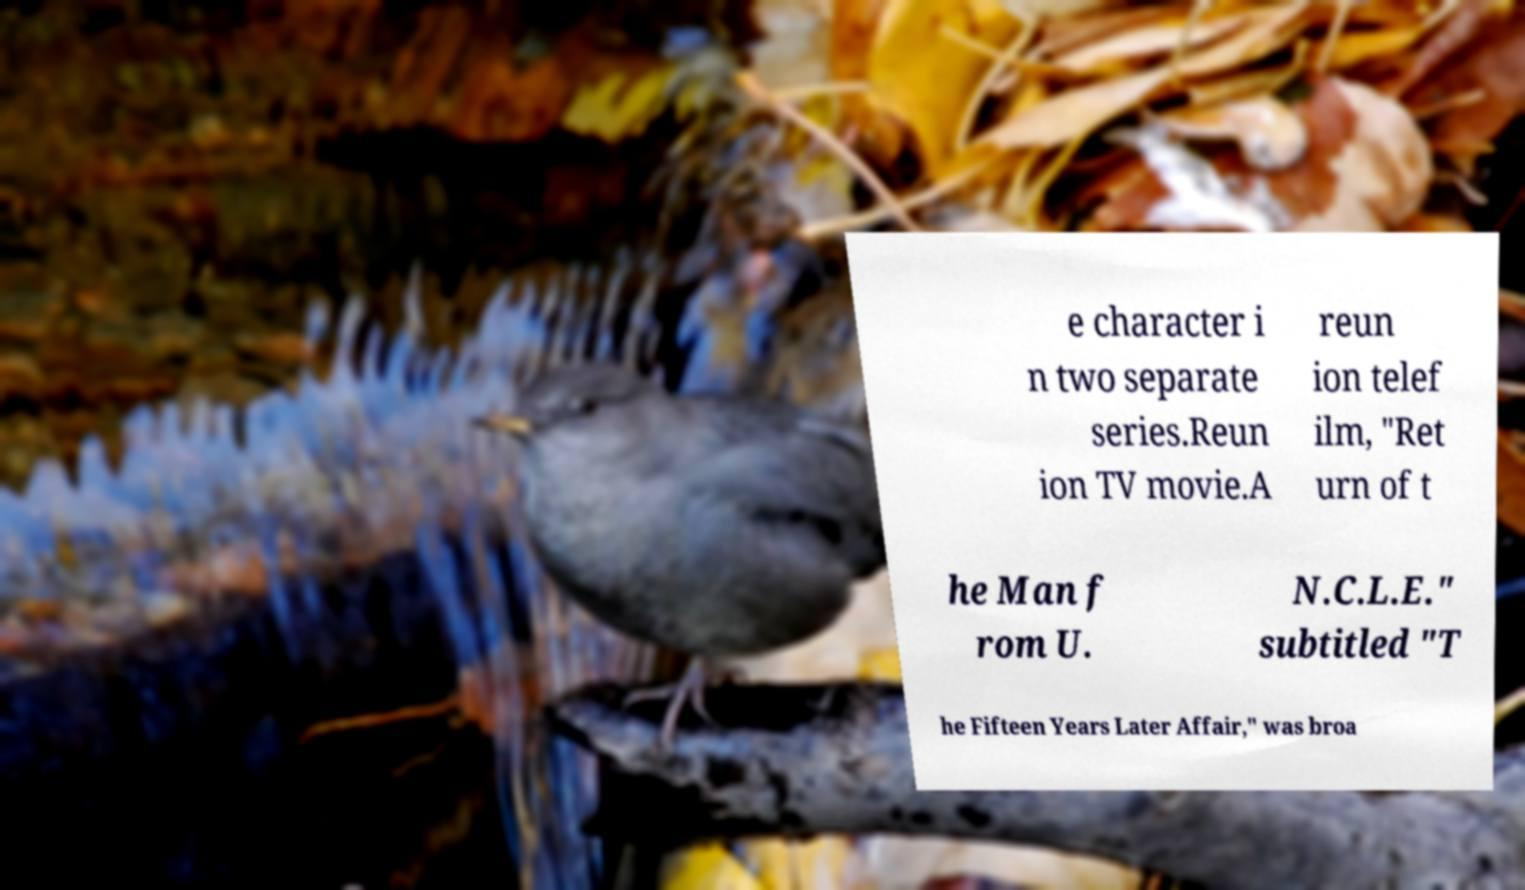Please identify and transcribe the text found in this image. e character i n two separate series.Reun ion TV movie.A reun ion telef ilm, "Ret urn of t he Man f rom U. N.C.L.E." subtitled "T he Fifteen Years Later Affair," was broa 